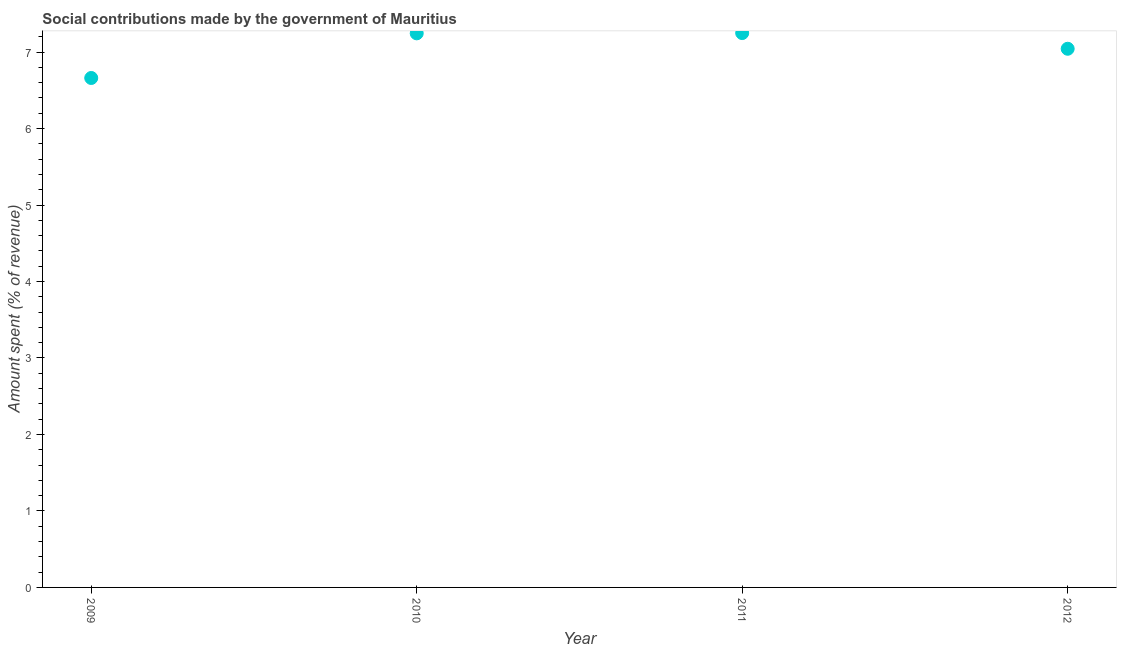What is the amount spent in making social contributions in 2011?
Offer a very short reply. 7.25. Across all years, what is the maximum amount spent in making social contributions?
Your response must be concise. 7.25. Across all years, what is the minimum amount spent in making social contributions?
Provide a succinct answer. 6.66. In which year was the amount spent in making social contributions maximum?
Give a very brief answer. 2011. In which year was the amount spent in making social contributions minimum?
Provide a succinct answer. 2009. What is the sum of the amount spent in making social contributions?
Your answer should be compact. 28.2. What is the difference between the amount spent in making social contributions in 2009 and 2010?
Ensure brevity in your answer.  -0.58. What is the average amount spent in making social contributions per year?
Your answer should be compact. 7.05. What is the median amount spent in making social contributions?
Ensure brevity in your answer.  7.14. What is the ratio of the amount spent in making social contributions in 2009 to that in 2010?
Provide a succinct answer. 0.92. What is the difference between the highest and the second highest amount spent in making social contributions?
Give a very brief answer. 0. What is the difference between the highest and the lowest amount spent in making social contributions?
Make the answer very short. 0.59. In how many years, is the amount spent in making social contributions greater than the average amount spent in making social contributions taken over all years?
Make the answer very short. 2. Does the amount spent in making social contributions monotonically increase over the years?
Give a very brief answer. No. How many years are there in the graph?
Your answer should be very brief. 4. Does the graph contain any zero values?
Offer a terse response. No. What is the title of the graph?
Offer a terse response. Social contributions made by the government of Mauritius. What is the label or title of the Y-axis?
Offer a very short reply. Amount spent (% of revenue). What is the Amount spent (% of revenue) in 2009?
Provide a succinct answer. 6.66. What is the Amount spent (% of revenue) in 2010?
Provide a succinct answer. 7.24. What is the Amount spent (% of revenue) in 2011?
Your answer should be very brief. 7.25. What is the Amount spent (% of revenue) in 2012?
Your answer should be very brief. 7.04. What is the difference between the Amount spent (% of revenue) in 2009 and 2010?
Keep it short and to the point. -0.58. What is the difference between the Amount spent (% of revenue) in 2009 and 2011?
Your response must be concise. -0.59. What is the difference between the Amount spent (% of revenue) in 2009 and 2012?
Provide a short and direct response. -0.38. What is the difference between the Amount spent (% of revenue) in 2010 and 2011?
Your answer should be very brief. -0. What is the difference between the Amount spent (% of revenue) in 2010 and 2012?
Provide a short and direct response. 0.2. What is the difference between the Amount spent (% of revenue) in 2011 and 2012?
Provide a succinct answer. 0.21. What is the ratio of the Amount spent (% of revenue) in 2009 to that in 2010?
Your answer should be compact. 0.92. What is the ratio of the Amount spent (% of revenue) in 2009 to that in 2011?
Your answer should be very brief. 0.92. What is the ratio of the Amount spent (% of revenue) in 2009 to that in 2012?
Your answer should be compact. 0.95. What is the ratio of the Amount spent (% of revenue) in 2010 to that in 2011?
Ensure brevity in your answer.  1. What is the ratio of the Amount spent (% of revenue) in 2010 to that in 2012?
Keep it short and to the point. 1.03. 